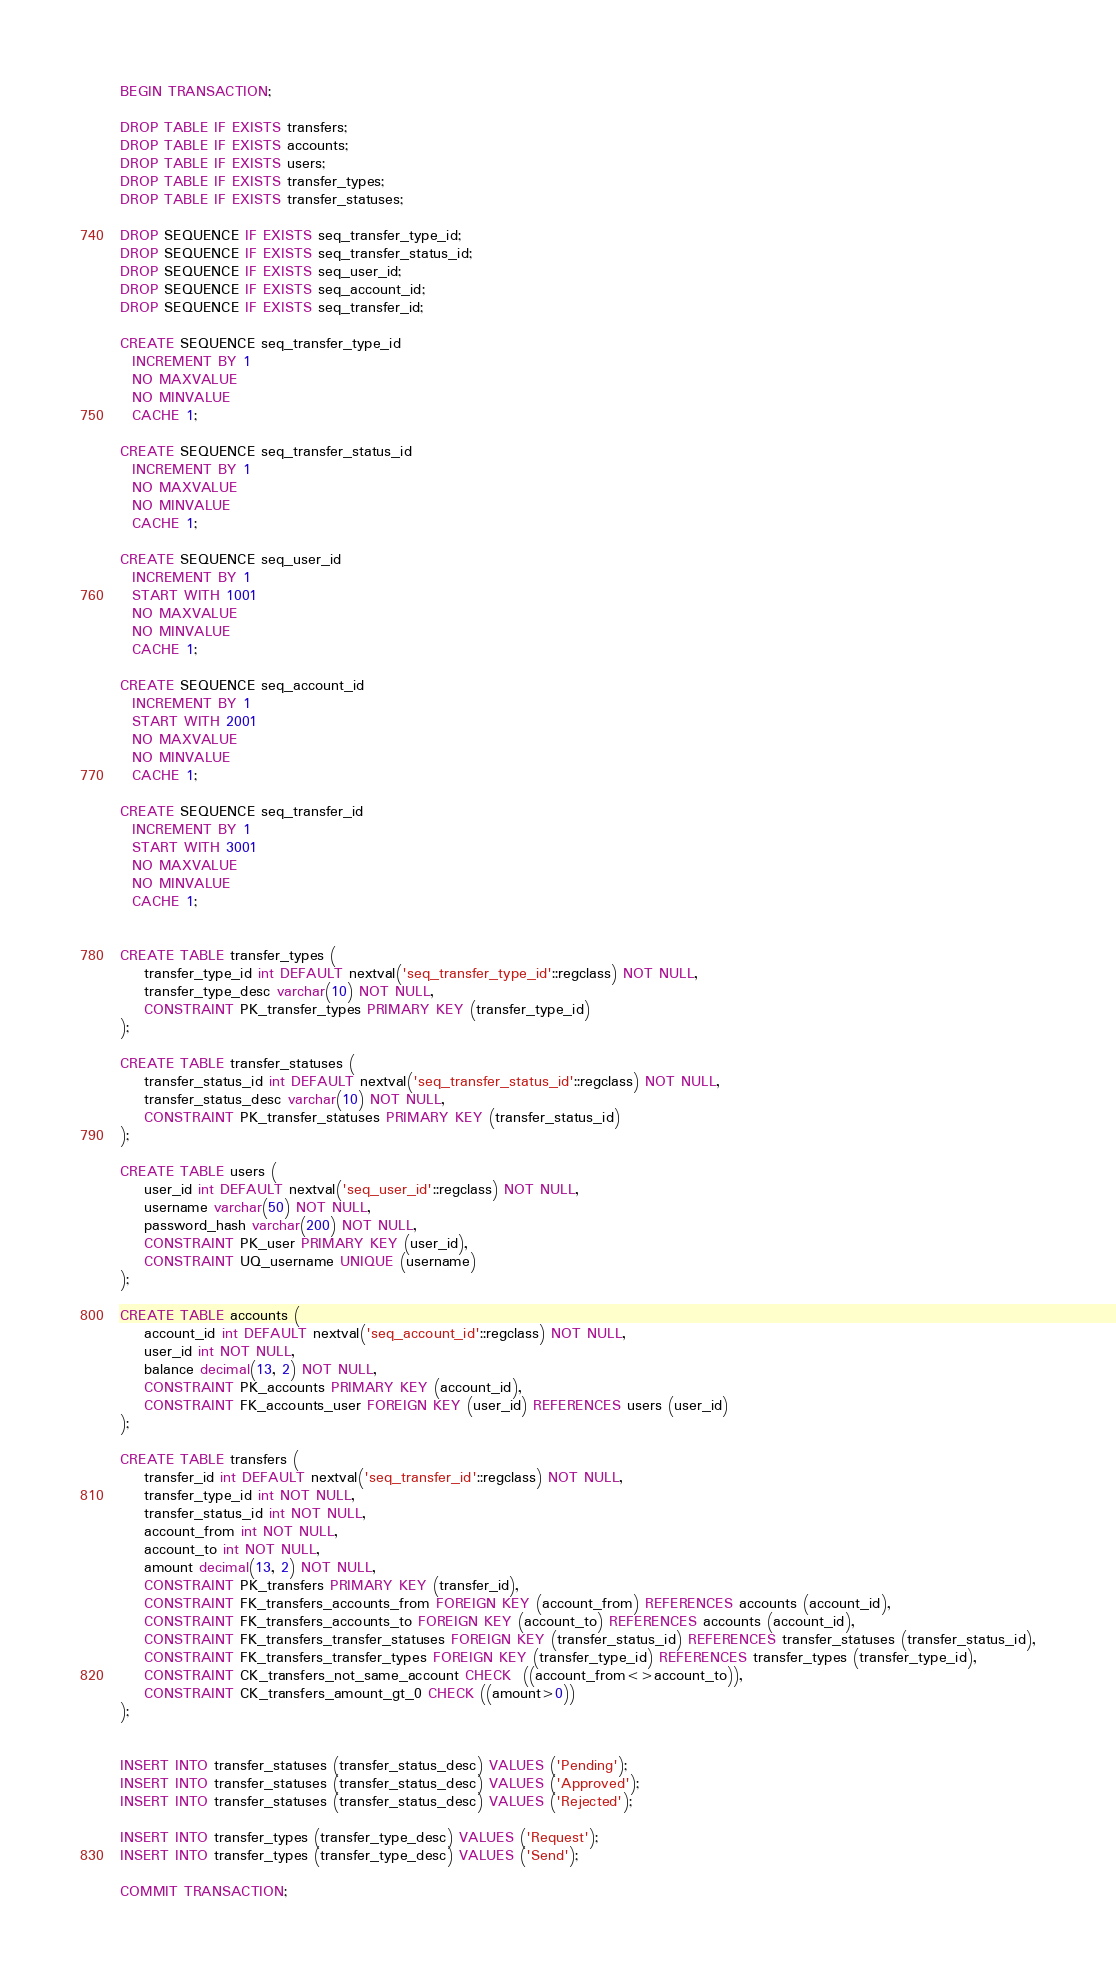<code> <loc_0><loc_0><loc_500><loc_500><_SQL_>BEGIN TRANSACTION;

DROP TABLE IF EXISTS transfers;
DROP TABLE IF EXISTS accounts;
DROP TABLE IF EXISTS users;
DROP TABLE IF EXISTS transfer_types;
DROP TABLE IF EXISTS transfer_statuses;

DROP SEQUENCE IF EXISTS seq_transfer_type_id;
DROP SEQUENCE IF EXISTS seq_transfer_status_id;
DROP SEQUENCE IF EXISTS seq_user_id;
DROP SEQUENCE IF EXISTS seq_account_id;
DROP SEQUENCE IF EXISTS seq_transfer_id;

CREATE SEQUENCE seq_transfer_type_id
  INCREMENT BY 1
  NO MAXVALUE
  NO MINVALUE
  CACHE 1;

CREATE SEQUENCE seq_transfer_status_id
  INCREMENT BY 1
  NO MAXVALUE
  NO MINVALUE
  CACHE 1;

CREATE SEQUENCE seq_user_id
  INCREMENT BY 1
  START WITH 1001
  NO MAXVALUE
  NO MINVALUE
  CACHE 1;

CREATE SEQUENCE seq_account_id
  INCREMENT BY 1
  START WITH 2001
  NO MAXVALUE
  NO MINVALUE
  CACHE 1;

CREATE SEQUENCE seq_transfer_id
  INCREMENT BY 1
  START WITH 3001
  NO MAXVALUE
  NO MINVALUE
  CACHE 1;


CREATE TABLE transfer_types (
	transfer_type_id int DEFAULT nextval('seq_transfer_type_id'::regclass) NOT NULL,
	transfer_type_desc varchar(10) NOT NULL,
	CONSTRAINT PK_transfer_types PRIMARY KEY (transfer_type_id)
);

CREATE TABLE transfer_statuses (
	transfer_status_id int DEFAULT nextval('seq_transfer_status_id'::regclass) NOT NULL,
	transfer_status_desc varchar(10) NOT NULL,
	CONSTRAINT PK_transfer_statuses PRIMARY KEY (transfer_status_id)
);

CREATE TABLE users (
	user_id int DEFAULT nextval('seq_user_id'::regclass) NOT NULL,
	username varchar(50) NOT NULL,
	password_hash varchar(200) NOT NULL,
	CONSTRAINT PK_user PRIMARY KEY (user_id),
	CONSTRAINT UQ_username UNIQUE (username)
);

CREATE TABLE accounts (
	account_id int DEFAULT nextval('seq_account_id'::regclass) NOT NULL,
	user_id int NOT NULL,
	balance decimal(13, 2) NOT NULL,
	CONSTRAINT PK_accounts PRIMARY KEY (account_id),
	CONSTRAINT FK_accounts_user FOREIGN KEY (user_id) REFERENCES users (user_id)
);

CREATE TABLE transfers (
	transfer_id int DEFAULT nextval('seq_transfer_id'::regclass) NOT NULL,
	transfer_type_id int NOT NULL,
	transfer_status_id int NOT NULL,
	account_from int NOT NULL,
	account_to int NOT NULL,
	amount decimal(13, 2) NOT NULL,
	CONSTRAINT PK_transfers PRIMARY KEY (transfer_id),
	CONSTRAINT FK_transfers_accounts_from FOREIGN KEY (account_from) REFERENCES accounts (account_id),
	CONSTRAINT FK_transfers_accounts_to FOREIGN KEY (account_to) REFERENCES accounts (account_id),
	CONSTRAINT FK_transfers_transfer_statuses FOREIGN KEY (transfer_status_id) REFERENCES transfer_statuses (transfer_status_id),
	CONSTRAINT FK_transfers_transfer_types FOREIGN KEY (transfer_type_id) REFERENCES transfer_types (transfer_type_id),
	CONSTRAINT CK_transfers_not_same_account CHECK  ((account_from<>account_to)),
	CONSTRAINT CK_transfers_amount_gt_0 CHECK ((amount>0))
);


INSERT INTO transfer_statuses (transfer_status_desc) VALUES ('Pending');
INSERT INTO transfer_statuses (transfer_status_desc) VALUES ('Approved');
INSERT INTO transfer_statuses (transfer_status_desc) VALUES ('Rejected');

INSERT INTO transfer_types (transfer_type_desc) VALUES ('Request');
INSERT INTO transfer_types (transfer_type_desc) VALUES ('Send');

COMMIT TRANSACTION;
</code> 